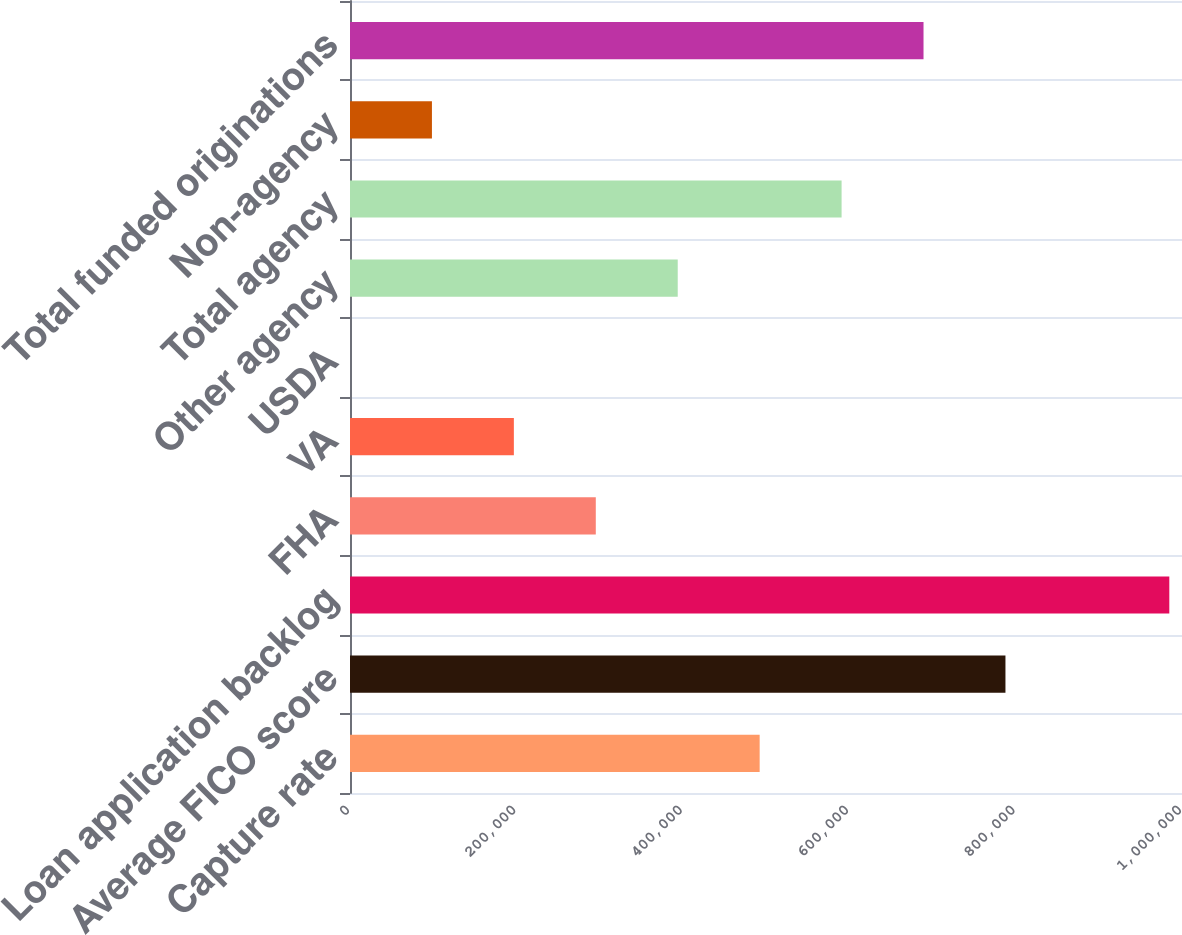<chart> <loc_0><loc_0><loc_500><loc_500><bar_chart><fcel>Capture rate<fcel>Average FICO score<fcel>Loan application backlog<fcel>FHA<fcel>VA<fcel>USDA<fcel>Other agency<fcel>Total agency<fcel>Non-agency<fcel>Total funded originations<nl><fcel>492378<fcel>787804<fcel>984754<fcel>295428<fcel>196953<fcel>3<fcel>393903<fcel>590854<fcel>98478.1<fcel>689329<nl></chart> 